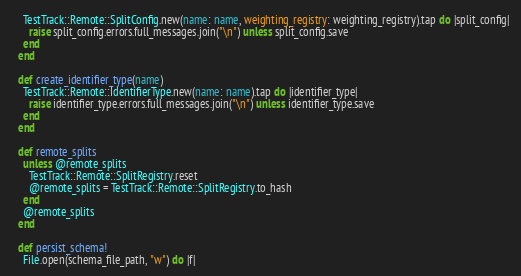Convert code to text. <code><loc_0><loc_0><loc_500><loc_500><_Ruby_>    TestTrack::Remote::SplitConfig.new(name: name, weighting_registry: weighting_registry).tap do |split_config|
      raise split_config.errors.full_messages.join("\n") unless split_config.save
    end
  end

  def create_identifier_type(name)
    TestTrack::Remote::IdentifierType.new(name: name).tap do |identifier_type|
      raise identifier_type.errors.full_messages.join("\n") unless identifier_type.save
    end
  end

  def remote_splits
    unless @remote_splits
      TestTrack::Remote::SplitRegistry.reset
      @remote_splits = TestTrack::Remote::SplitRegistry.to_hash
    end
    @remote_splits
  end

  def persist_schema!
    File.open(schema_file_path, "w") do |f|</code> 